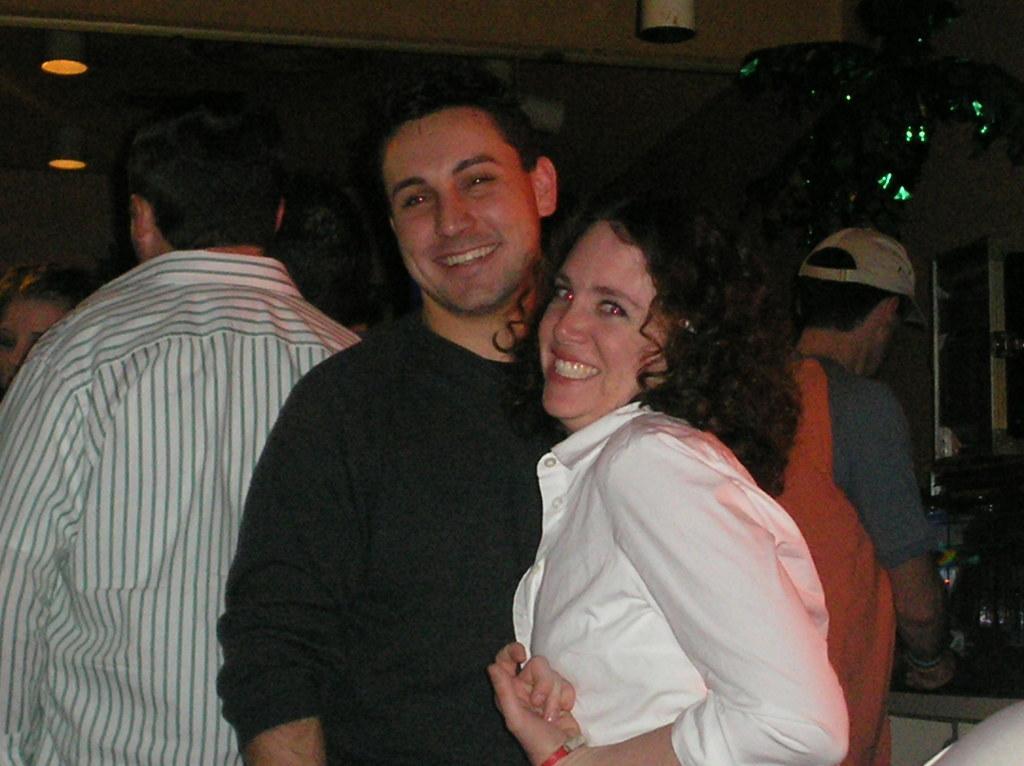How would you summarize this image in a sentence or two? There are people standing and these two people are smiling. Background we can see wall and lights. 